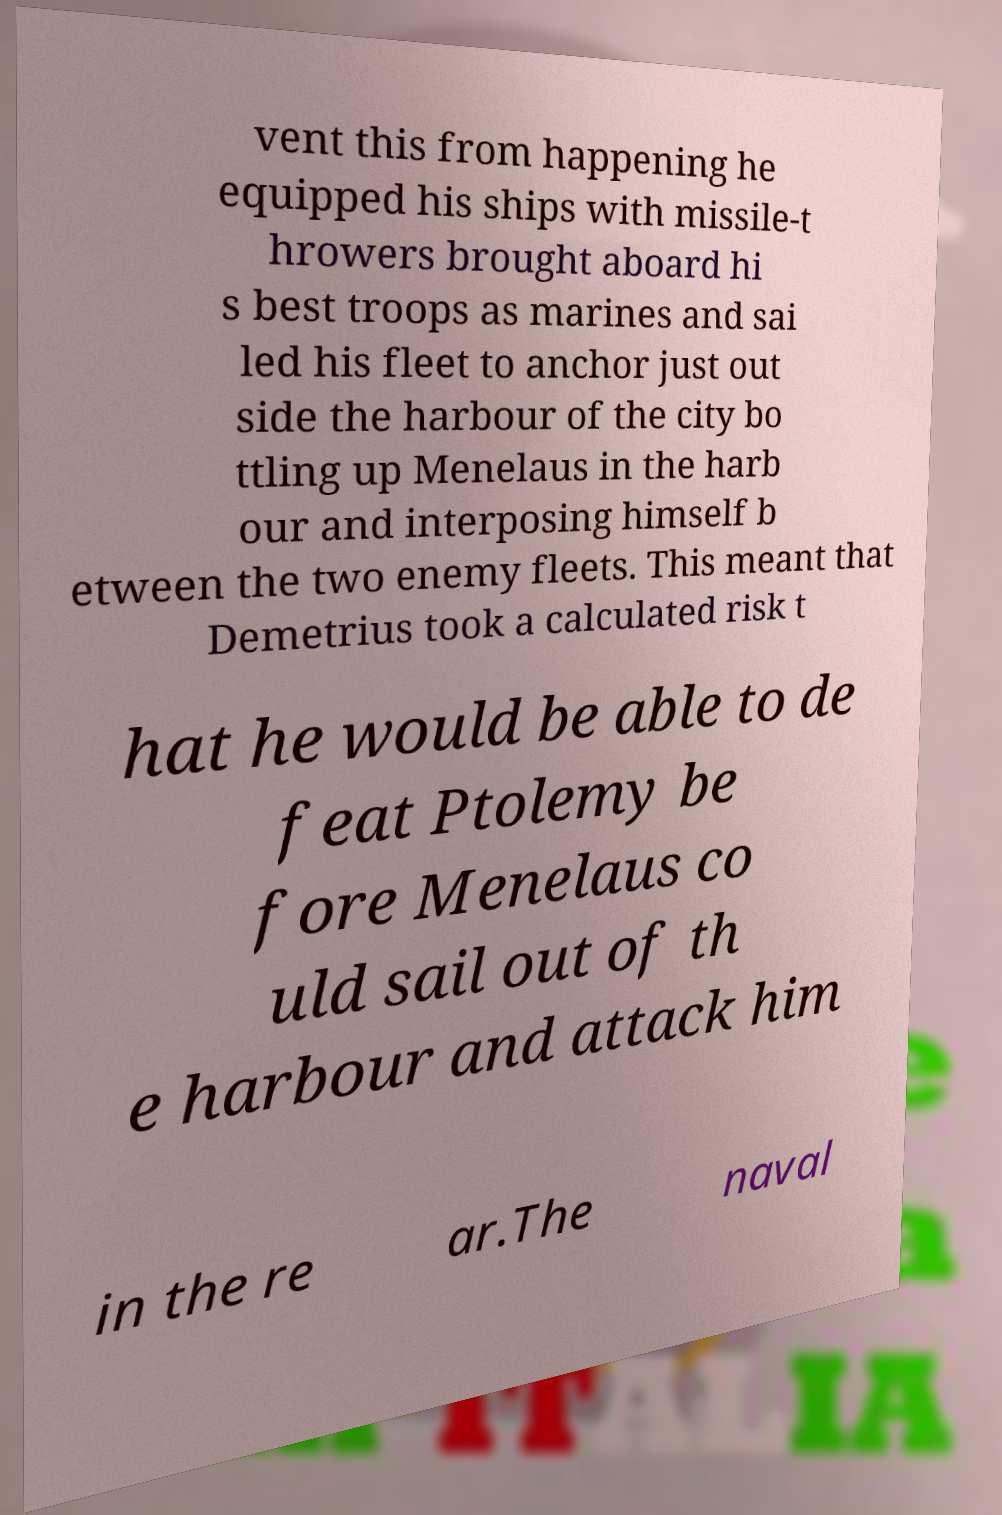Could you extract and type out the text from this image? vent this from happening he equipped his ships with missile-t hrowers brought aboard hi s best troops as marines and sai led his fleet to anchor just out side the harbour of the city bo ttling up Menelaus in the harb our and interposing himself b etween the two enemy fleets. This meant that Demetrius took a calculated risk t hat he would be able to de feat Ptolemy be fore Menelaus co uld sail out of th e harbour and attack him in the re ar.The naval 